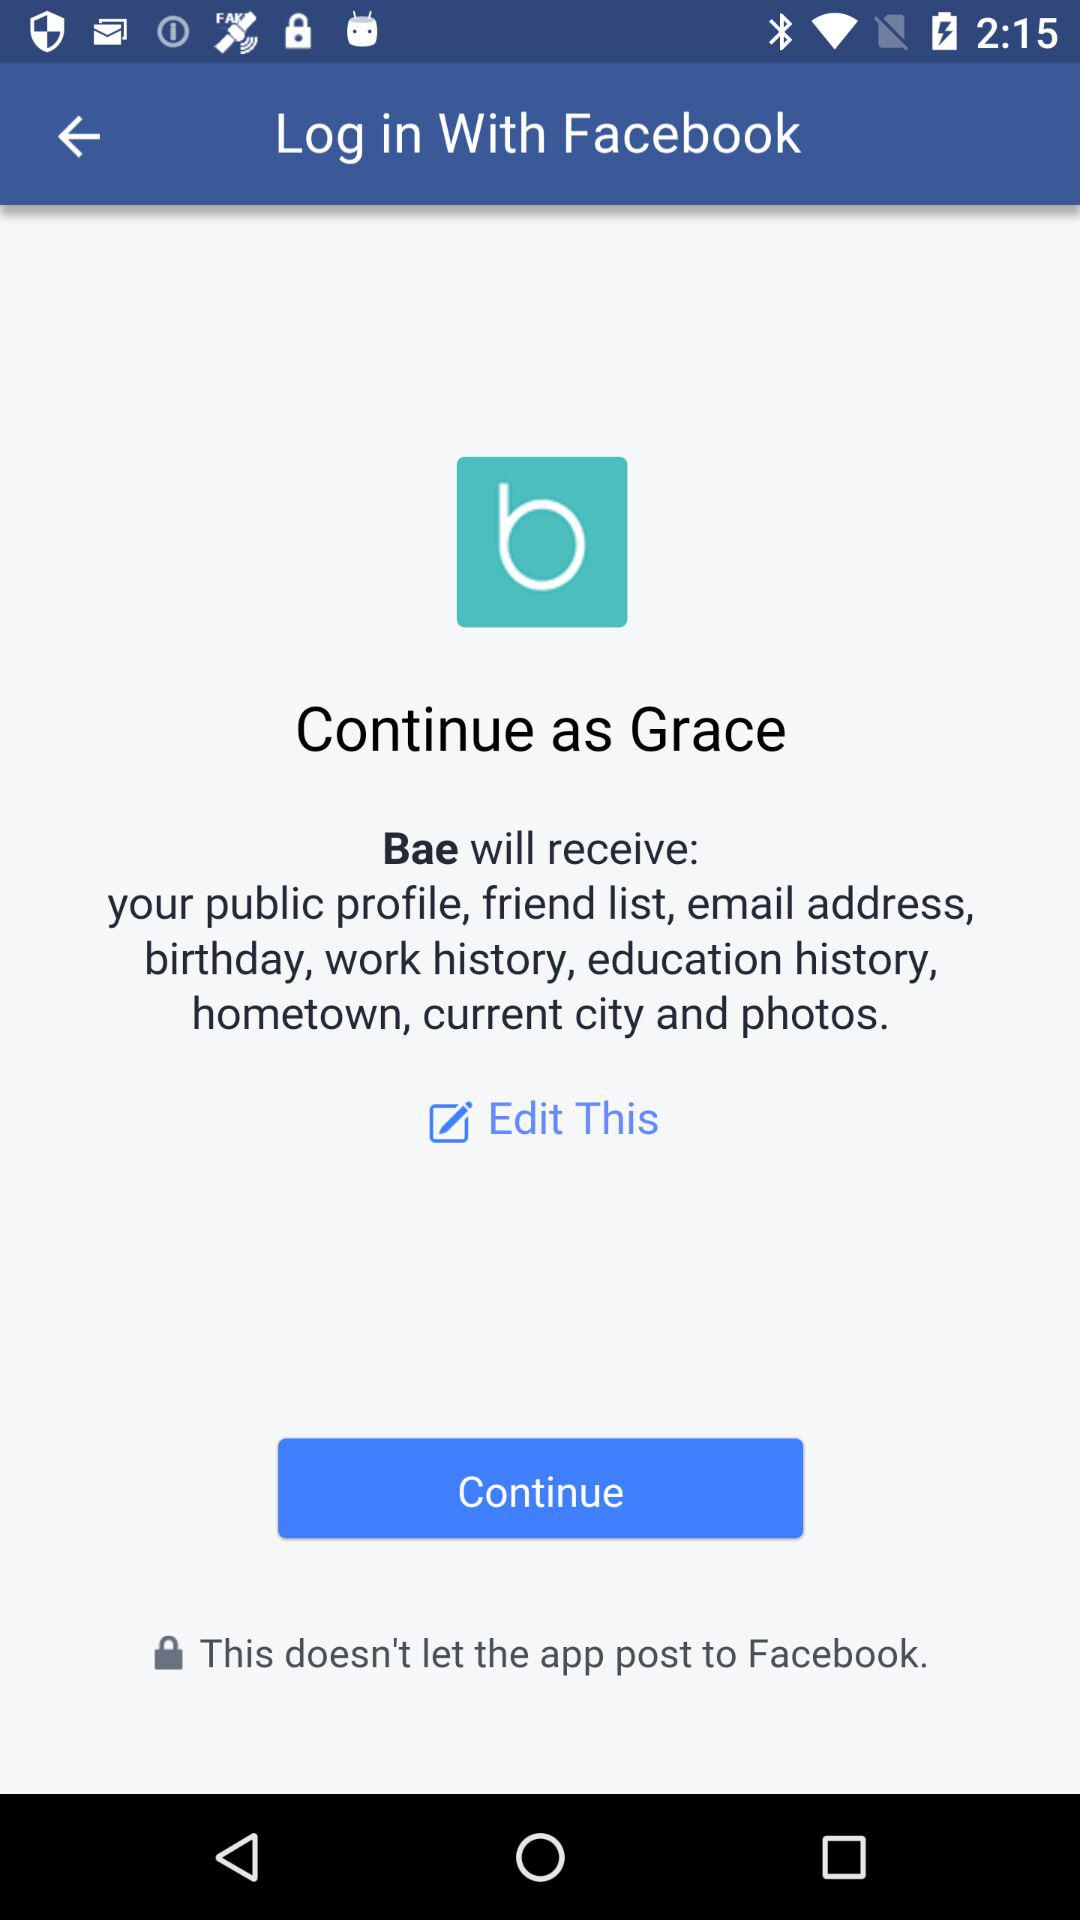What application will receive my public profile, email address, friend list, birthday, work history and hometown? The application "Bae" will receive your public profile, email address, friend list, birthday, work history and hometown. 